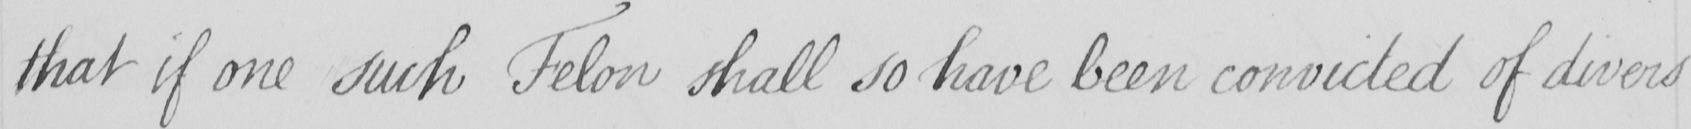Transcribe the text shown in this historical manuscript line. that if one such Felon shall so have been convicted of divers 